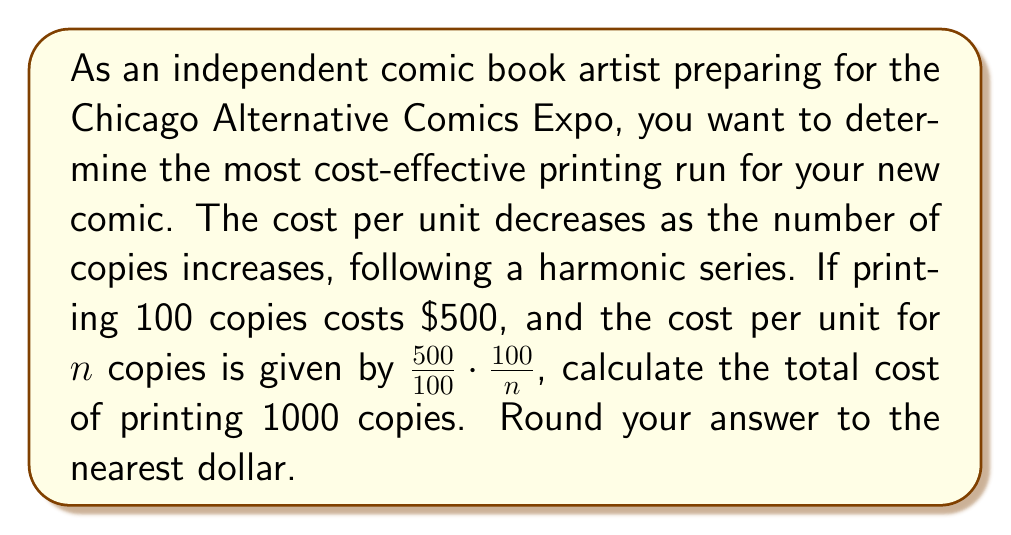Can you solve this math problem? Let's approach this step-by-step:

1) The cost per unit for $n$ copies is given by:
   $$\text{Cost per unit} = \frac{500}{100} \cdot \frac{100}{n} = \frac{500}{n}$$

2) To find the total cost, we need to sum this cost for all values of $n$ from 1 to 1000:
   $$\text{Total Cost} = \sum_{n=1}^{1000} \frac{500}{n}$$

3) This is a harmonic series multiplied by 500. We can factor out 500:
   $$\text{Total Cost} = 500 \sum_{n=1}^{1000} \frac{1}{n}$$

4) The sum of reciprocals from 1 to 1000 is approximately equal to the natural logarithm of 1000 plus the Euler-Mascheroni constant:
   $$\sum_{n=1}^{1000} \frac{1}{n} \approx \ln(1000) + \gamma$$
   Where $\gamma \approx 0.5772156649$ (Euler-Mascheroni constant)

5) Let's calculate:
   $$\ln(1000) + \gamma \approx 6.907755278 + 0.5772156649 \approx 7.484970943$$

6) Now, multiply by 500:
   $$500 \cdot 7.484970943 \approx 3742.485471$$

7) Rounding to the nearest dollar:
   $$3742.485471 \approx 3742$$
Answer: $3742 